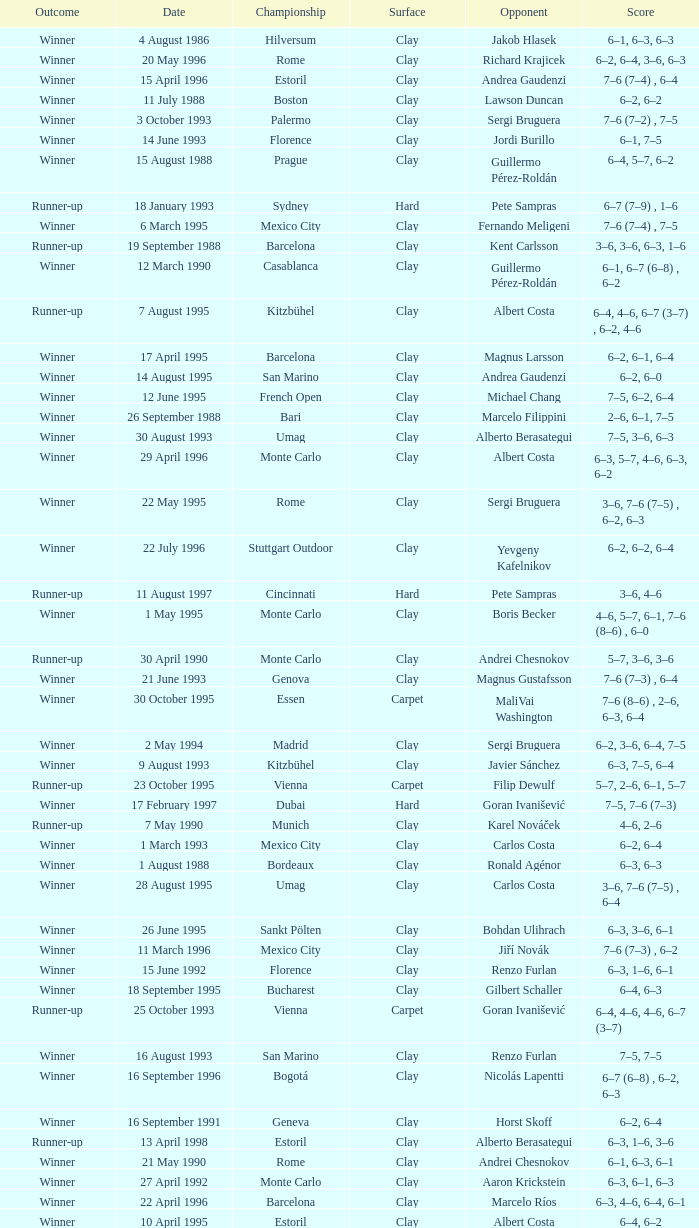What is the surface on 21 june 1993? Clay. 